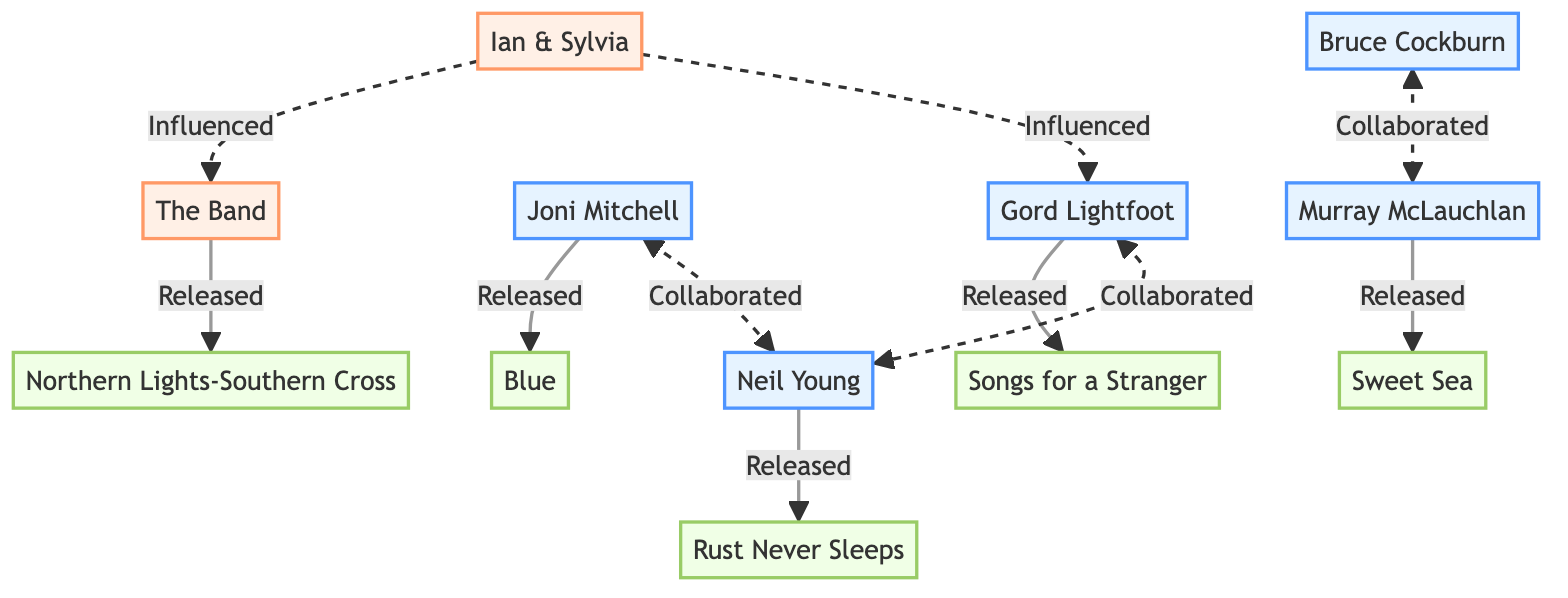What is the title of the album released by The Band? The diagram shows that the album released by The Band is "Northern Lights-Southern Cross."
Answer: Northern Lights-Southern Cross How many artists are listed in the diagram? By counting the nodes labeled with the artist class, there are five artists in total: Gord Lightfoot, Bruce Cockburn, Joni Mitchell, Neil Young, and Murray McLauchlan.
Answer: 5 Which artist collaborated with Bruce Cockburn? The diagram indicates that Bruce Cockburn collaborated with Murray McLauchlan, as shown by the connection labeled "Collaborated."
Answer: Murray McLauchlan What was the title of the album released by Neil Young? The diagram indicates that Neil Young released the album titled "Rust Never Sleeps."
Answer: Rust Never Sleeps Who influenced The Band according to the diagram? The diagram shows a dashed line labeled "Influenced" from Ian & Sylvia to The Band, indicating that Ian & Sylvia influenced The Band.
Answer: Ian & Sylvia Which two artists are connected through collaboration? The diagram features collaboration links: Gord Lightfoot and Neil Young, as well as Joni Mitchell and Neil Young. This requires identifying both pairs connected by dashed lines indicating collaboration.
Answer: Gord Lightfoot and Neil Young, Joni Mitchell and Neil Young What type of relationship is shown between Ian & Sylvia and Gord Lightfoot? The diagram depicts a dashed line labeled "Influenced" from Ian & Sylvia to Gord Lightfoot, indicating an influence relationship.
Answer: Influenced What type of links connect the bands and albums in the diagram? The diagram features solid links labeled "Released" connecting each band with the album they released, indicating a direct release relationship.
Answer: Released 